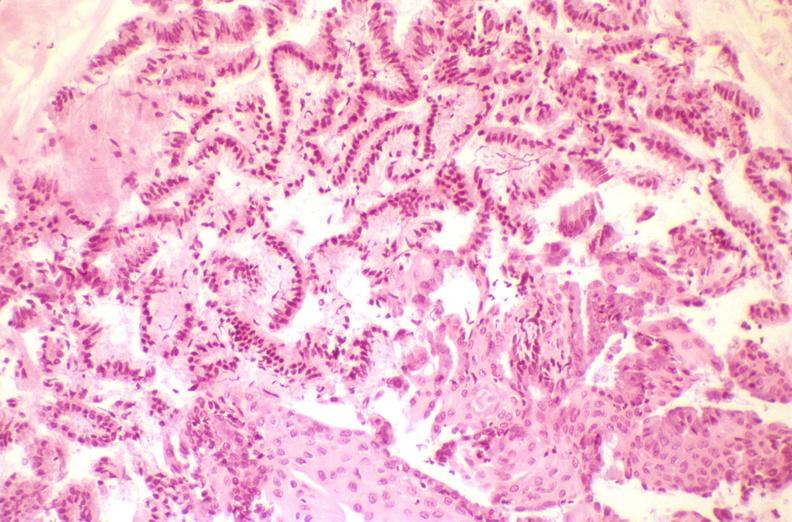what is present?
Answer the question using a single word or phrase. Female reproductive 